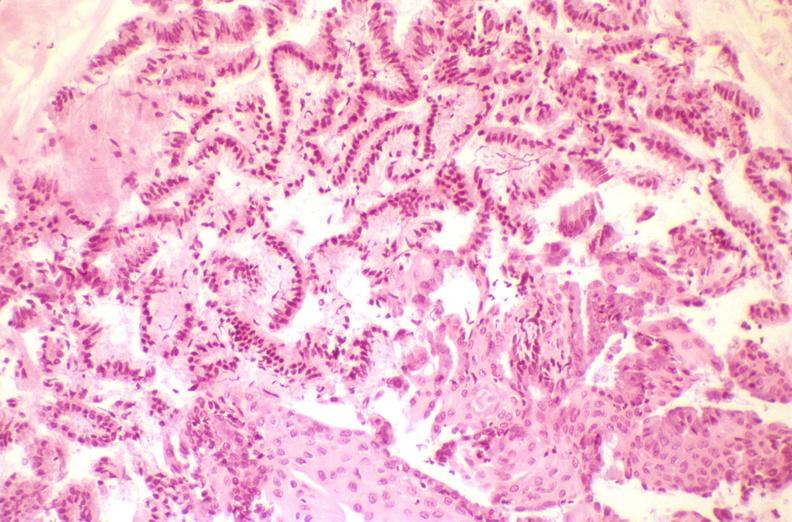what is present?
Answer the question using a single word or phrase. Female reproductive 